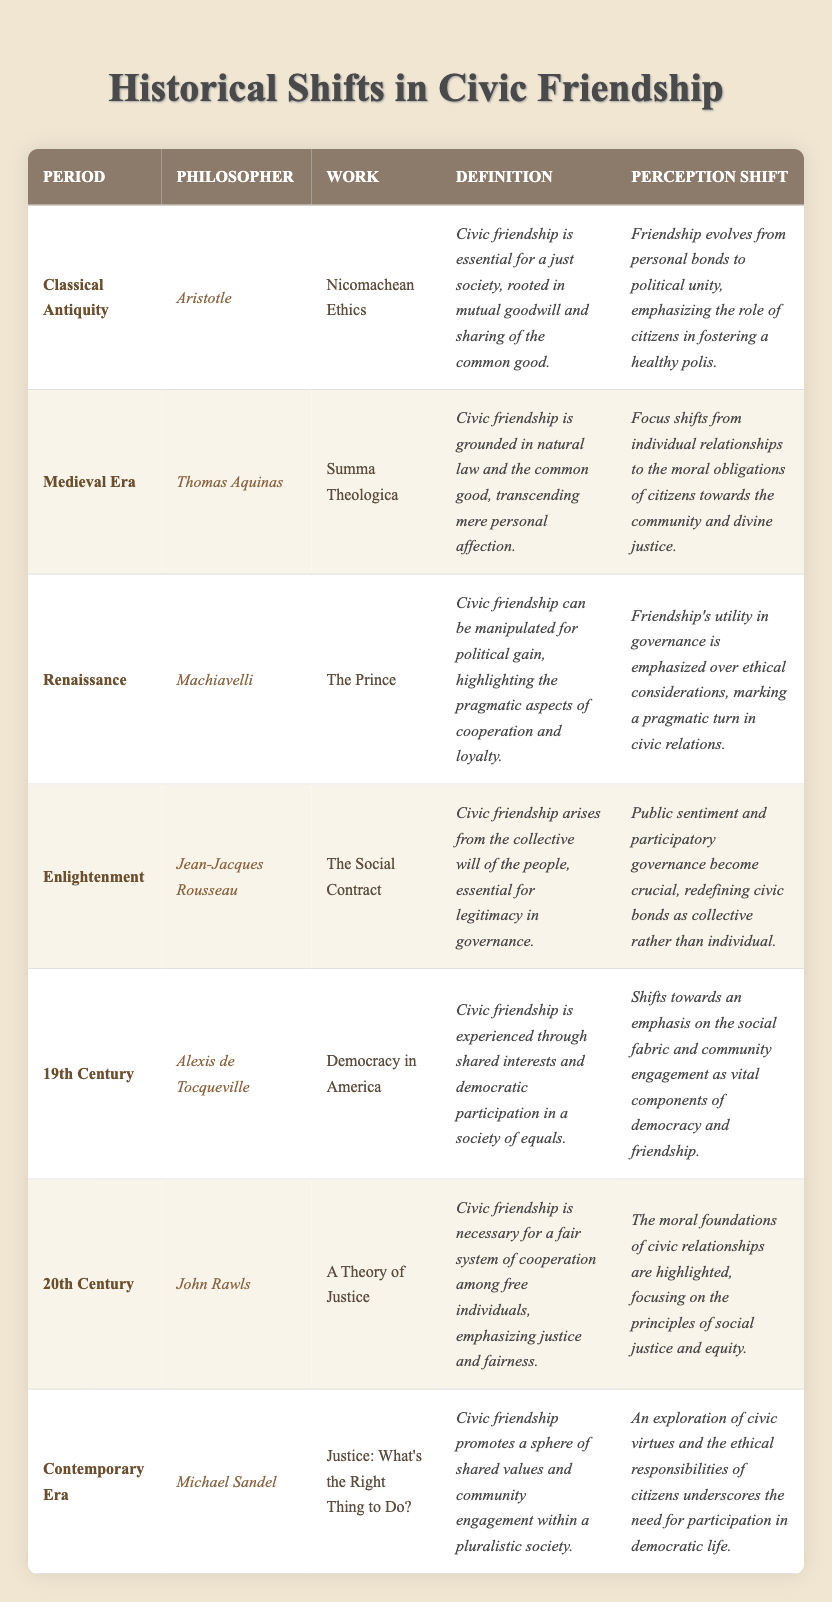What is the definition of civic friendship according to Aristotle? According to the table, Aristotle's definition of civic friendship states that it is essential for a just society, rooted in mutual goodwill and sharing of the common good.
Answer: Civic friendship is essential for a just society, rooted in mutual goodwill and sharing of the common good Who wrote "Democracy in America"? The table indicates that Alexis de Tocqueville is the philosopher who authored "Democracy in America".
Answer: Alexis de Tocqueville What shift in perception of civic friendship occurs during the Medieval Era? The table notes that during the Medieval Era, the focus shifts from individual relationships to the moral obligations of citizens towards the community and divine justice.
Answer: The focus shifts to moral obligations of citizens towards the community What is the main emphasis of civic friendship in the Renaissance period? The table highlights that the emphasis in the Renaissance is on the manipulation of civic friendship for political gain, focusing on pragmatic aspects like cooperation and loyalty.
Answer: Emphasis on manipulation for political gain and pragmatic cooperation In which period is civic friendship connected to the collective will of the people? The table specifies that civic friendship is connected to the collective will of the people during the Enlightenment, as presented by Jean-Jacques Rousseau.
Answer: Enlightenment Which philosopher's work emphasizes justice and fairness in civic friendship? John Rawls' work, "A Theory of Justice," emphasizes justice and fairness in civic friendship according to the table.
Answer: John Rawls What is the definition of civic friendship in the Contemporary Era? The table reveals that Michael Sandel defines civic friendship as promoting a sphere of shared values and community engagement within a pluralistic society.
Answer: Promotes shared values and community engagement How did the perception of civic friendship evolve from Classical Antiquity to the 20th Century? The table shows that it evolved from an emphasis on mutual goodwill and political unity in Classical Antiquity to highlighting moral foundations and social justice principles in the 20th Century, notably by John Rawls.
Answer: From mutual goodwill to moral foundations and social justice True or False: Machiavelli believed civic friendship should be rooted in ethical considerations. The table indicates that Machiavelli emphasized the pragmatic aspects of civic friendship, suggesting he did not prioritize ethical considerations.
Answer: False What key transition in civic friendship can be observed from the Medieval Era to the Renaissance? The table illustrates a transition from focusing on moral obligations towards community and divine justice in the Medieval Era to emphasizing the pragmatic utility of friendship in governance during the Renaissance.
Answer: From moral obligations to pragmatic utility How does the perception of civic friendship in the 19th Century emphasize community engagement? The table specifies that in the 19th Century, civic friendship is experienced through shared interests and democratic participation, highlighting the importance of social fabric and community engagement.
Answer: It emphasizes shared interests and democratic participation 